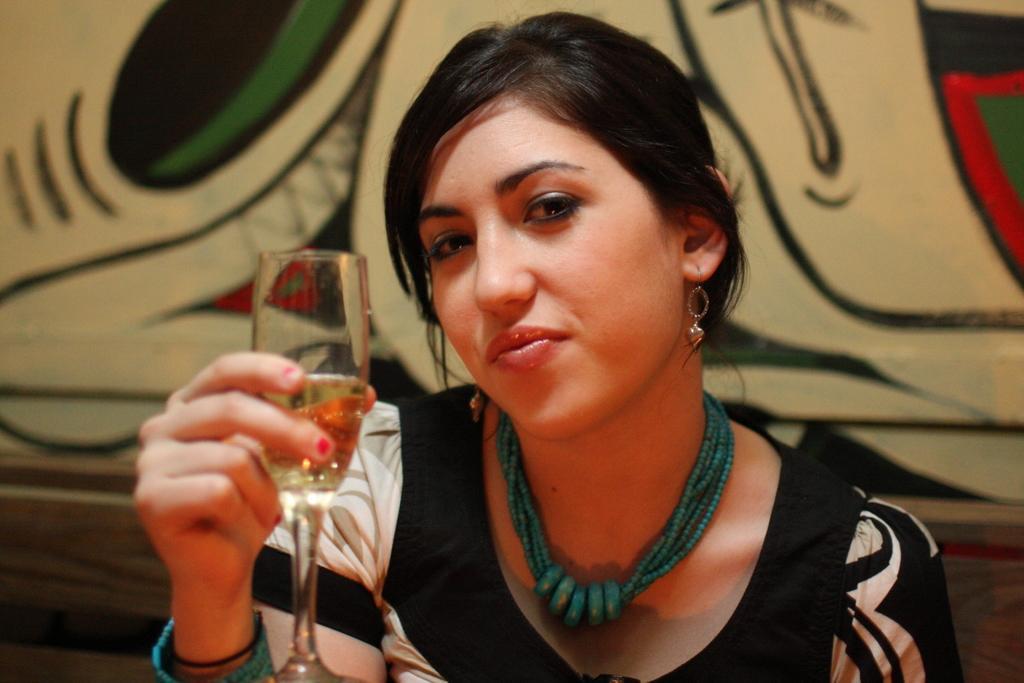Can you describe this image briefly? A lady with black dress is sitting. In her hand there is a glass. Around her neck there is a chain. 